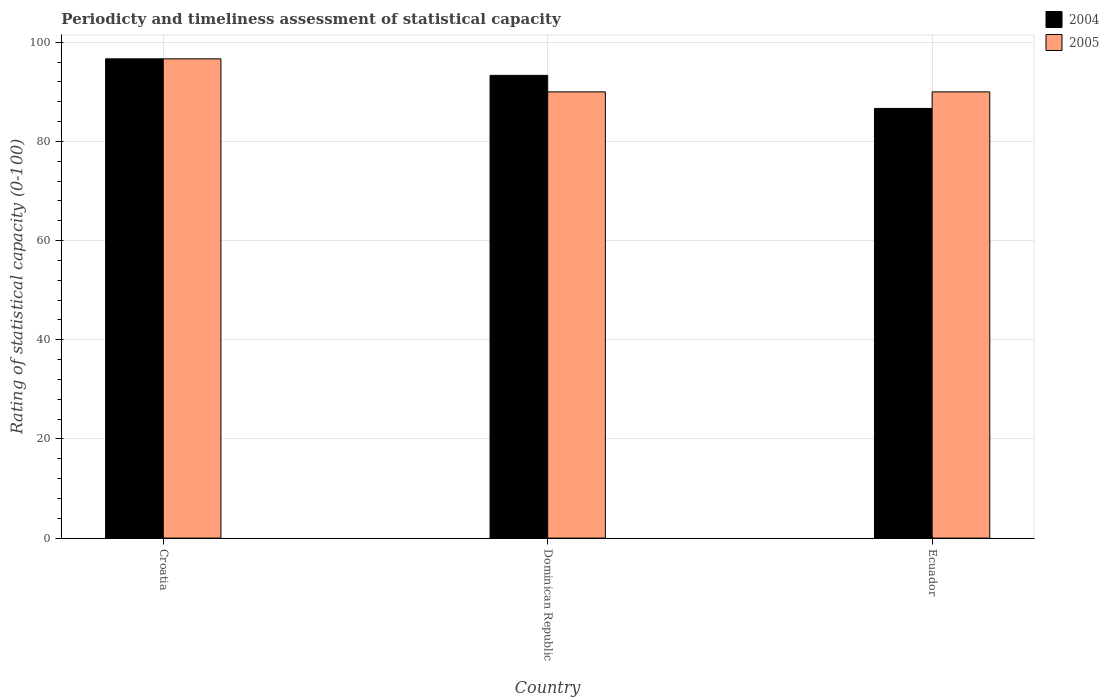How many different coloured bars are there?
Offer a terse response. 2. How many groups of bars are there?
Ensure brevity in your answer.  3. Are the number of bars on each tick of the X-axis equal?
Ensure brevity in your answer.  Yes. How many bars are there on the 3rd tick from the left?
Your answer should be very brief. 2. How many bars are there on the 2nd tick from the right?
Make the answer very short. 2. What is the label of the 2nd group of bars from the left?
Offer a terse response. Dominican Republic. In how many cases, is the number of bars for a given country not equal to the number of legend labels?
Provide a succinct answer. 0. What is the rating of statistical capacity in 2004 in Dominican Republic?
Your answer should be compact. 93.33. Across all countries, what is the maximum rating of statistical capacity in 2004?
Keep it short and to the point. 96.67. Across all countries, what is the minimum rating of statistical capacity in 2004?
Your response must be concise. 86.67. In which country was the rating of statistical capacity in 2005 maximum?
Provide a short and direct response. Croatia. In which country was the rating of statistical capacity in 2004 minimum?
Offer a very short reply. Ecuador. What is the total rating of statistical capacity in 2005 in the graph?
Give a very brief answer. 276.67. What is the difference between the rating of statistical capacity in 2005 in Dominican Republic and that in Ecuador?
Keep it short and to the point. 0. What is the difference between the rating of statistical capacity in 2004 in Ecuador and the rating of statistical capacity in 2005 in Croatia?
Make the answer very short. -10. What is the average rating of statistical capacity in 2004 per country?
Provide a succinct answer. 92.22. What is the ratio of the rating of statistical capacity in 2004 in Dominican Republic to that in Ecuador?
Your answer should be very brief. 1.08. Is the difference between the rating of statistical capacity in 2004 in Dominican Republic and Ecuador greater than the difference between the rating of statistical capacity in 2005 in Dominican Republic and Ecuador?
Provide a short and direct response. Yes. What is the difference between the highest and the second highest rating of statistical capacity in 2005?
Ensure brevity in your answer.  6.67. What is the difference between the highest and the lowest rating of statistical capacity in 2004?
Ensure brevity in your answer.  10. Is the sum of the rating of statistical capacity in 2004 in Dominican Republic and Ecuador greater than the maximum rating of statistical capacity in 2005 across all countries?
Provide a short and direct response. Yes. How many bars are there?
Your answer should be compact. 6. Are all the bars in the graph horizontal?
Give a very brief answer. No. How many countries are there in the graph?
Your answer should be compact. 3. What is the difference between two consecutive major ticks on the Y-axis?
Offer a terse response. 20. Does the graph contain any zero values?
Your response must be concise. No. How many legend labels are there?
Give a very brief answer. 2. How are the legend labels stacked?
Your response must be concise. Vertical. What is the title of the graph?
Your response must be concise. Periodicty and timeliness assessment of statistical capacity. What is the label or title of the Y-axis?
Ensure brevity in your answer.  Rating of statistical capacity (0-100). What is the Rating of statistical capacity (0-100) of 2004 in Croatia?
Ensure brevity in your answer.  96.67. What is the Rating of statistical capacity (0-100) in 2005 in Croatia?
Keep it short and to the point. 96.67. What is the Rating of statistical capacity (0-100) in 2004 in Dominican Republic?
Provide a succinct answer. 93.33. What is the Rating of statistical capacity (0-100) in 2005 in Dominican Republic?
Provide a short and direct response. 90. What is the Rating of statistical capacity (0-100) of 2004 in Ecuador?
Your answer should be compact. 86.67. What is the Rating of statistical capacity (0-100) of 2005 in Ecuador?
Provide a short and direct response. 90. Across all countries, what is the maximum Rating of statistical capacity (0-100) in 2004?
Your response must be concise. 96.67. Across all countries, what is the maximum Rating of statistical capacity (0-100) in 2005?
Your answer should be very brief. 96.67. Across all countries, what is the minimum Rating of statistical capacity (0-100) in 2004?
Your answer should be very brief. 86.67. What is the total Rating of statistical capacity (0-100) in 2004 in the graph?
Provide a succinct answer. 276.67. What is the total Rating of statistical capacity (0-100) in 2005 in the graph?
Offer a terse response. 276.67. What is the difference between the Rating of statistical capacity (0-100) of 2004 in Croatia and that in Dominican Republic?
Keep it short and to the point. 3.33. What is the difference between the Rating of statistical capacity (0-100) of 2005 in Croatia and that in Dominican Republic?
Keep it short and to the point. 6.67. What is the difference between the Rating of statistical capacity (0-100) of 2004 in Croatia and that in Ecuador?
Ensure brevity in your answer.  10. What is the difference between the Rating of statistical capacity (0-100) of 2005 in Croatia and that in Ecuador?
Keep it short and to the point. 6.67. What is the difference between the Rating of statistical capacity (0-100) of 2005 in Dominican Republic and that in Ecuador?
Your response must be concise. 0. What is the difference between the Rating of statistical capacity (0-100) of 2004 in Croatia and the Rating of statistical capacity (0-100) of 2005 in Dominican Republic?
Ensure brevity in your answer.  6.67. What is the average Rating of statistical capacity (0-100) of 2004 per country?
Offer a very short reply. 92.22. What is the average Rating of statistical capacity (0-100) of 2005 per country?
Your answer should be compact. 92.22. What is the ratio of the Rating of statistical capacity (0-100) in 2004 in Croatia to that in Dominican Republic?
Provide a succinct answer. 1.04. What is the ratio of the Rating of statistical capacity (0-100) in 2005 in Croatia to that in Dominican Republic?
Make the answer very short. 1.07. What is the ratio of the Rating of statistical capacity (0-100) of 2004 in Croatia to that in Ecuador?
Give a very brief answer. 1.12. What is the ratio of the Rating of statistical capacity (0-100) of 2005 in Croatia to that in Ecuador?
Your answer should be compact. 1.07. What is the difference between the highest and the second highest Rating of statistical capacity (0-100) of 2005?
Provide a succinct answer. 6.67. What is the difference between the highest and the lowest Rating of statistical capacity (0-100) in 2004?
Your answer should be very brief. 10. What is the difference between the highest and the lowest Rating of statistical capacity (0-100) in 2005?
Offer a terse response. 6.67. 